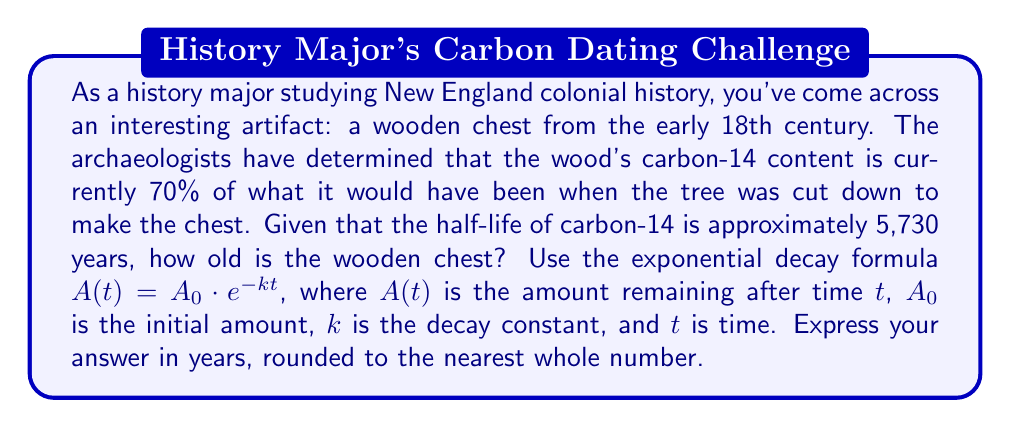Can you solve this math problem? To solve this problem, we'll use the exponential decay formula and logarithms. Let's break it down step-by-step:

1) We're given the exponential decay formula: $A(t) = A_0 \cdot e^{-kt}$

2) We know that the current amount is 70% of the original, so:
   $A(t) = 0.70A_0$

3) Substituting this into the formula:
   $0.70A_0 = A_0 \cdot e^{-kt}$

4) Simplify by dividing both sides by $A_0$:
   $0.70 = e^{-kt}$

5) To solve for $t$, we need to take the natural logarithm of both sides:
   $\ln(0.70) = \ln(e^{-kt})$

6) Simplify the right side using the properties of logarithms:
   $\ln(0.70) = -kt$

7) Solve for $t$:
   $t = -\frac{\ln(0.70)}{k}$

8) We need to find $k$. We can do this using the half-life formula:
   $k = \frac{\ln(2)}{t_{1/2}} = \frac{\ln(2)}{5730}$

9) Now substitute this into our equation for $t$:
   $t = -\frac{\ln(0.70)}{\frac{\ln(2)}{5730}}$

10) Simplify:
    $t = -\frac{5730 \cdot \ln(0.70)}{\ln(2)}$

11) Calculate (using a calculator):
    $t \approx 2878.5$ years

12) Rounding to the nearest whole number:
    $t = 2879$ years
Answer: 2879 years 